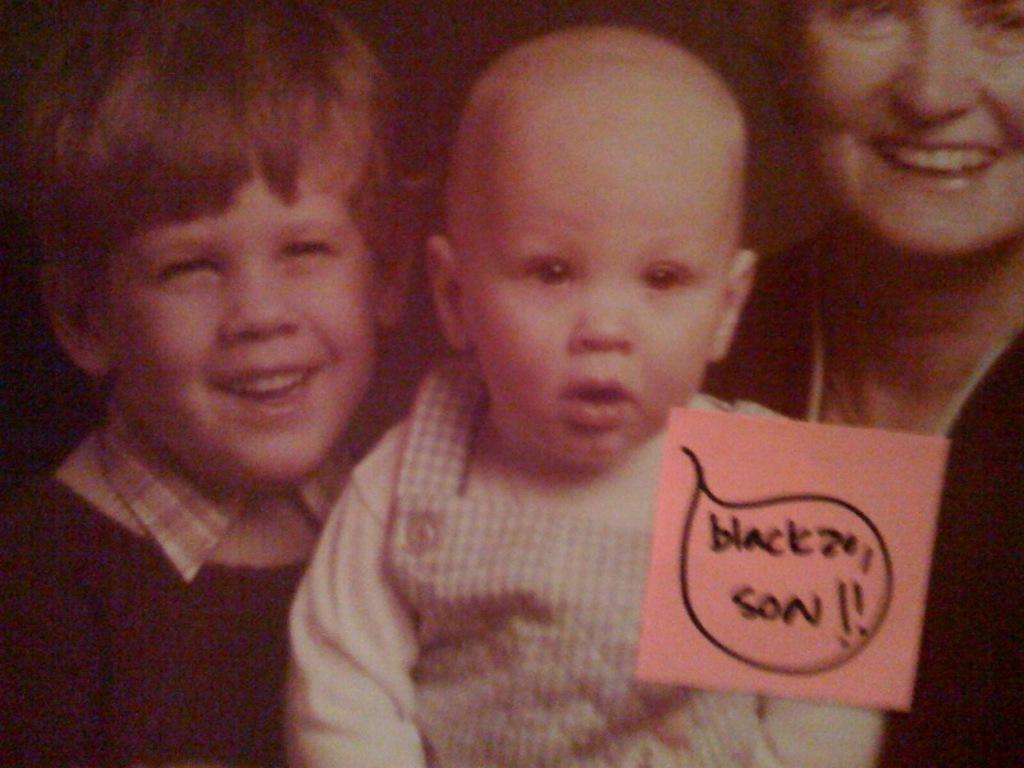How many people are in the image? There are people in the image. Can you describe the expressions on their faces? Two of the people are smiling. What can be observed about the background of the image? The background is blurred. Is there any text visible in the image? Yes, there is some text visible in the image. What type of berry is being held by the person in the image? There is no berry present in the image. How does the balloon affect the movement of the people in the image? There is no balloon present in the image, so it does not affect the movement of the people. 